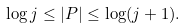<formula> <loc_0><loc_0><loc_500><loc_500>\log j \leq | P | \leq \log ( j + 1 ) .</formula> 